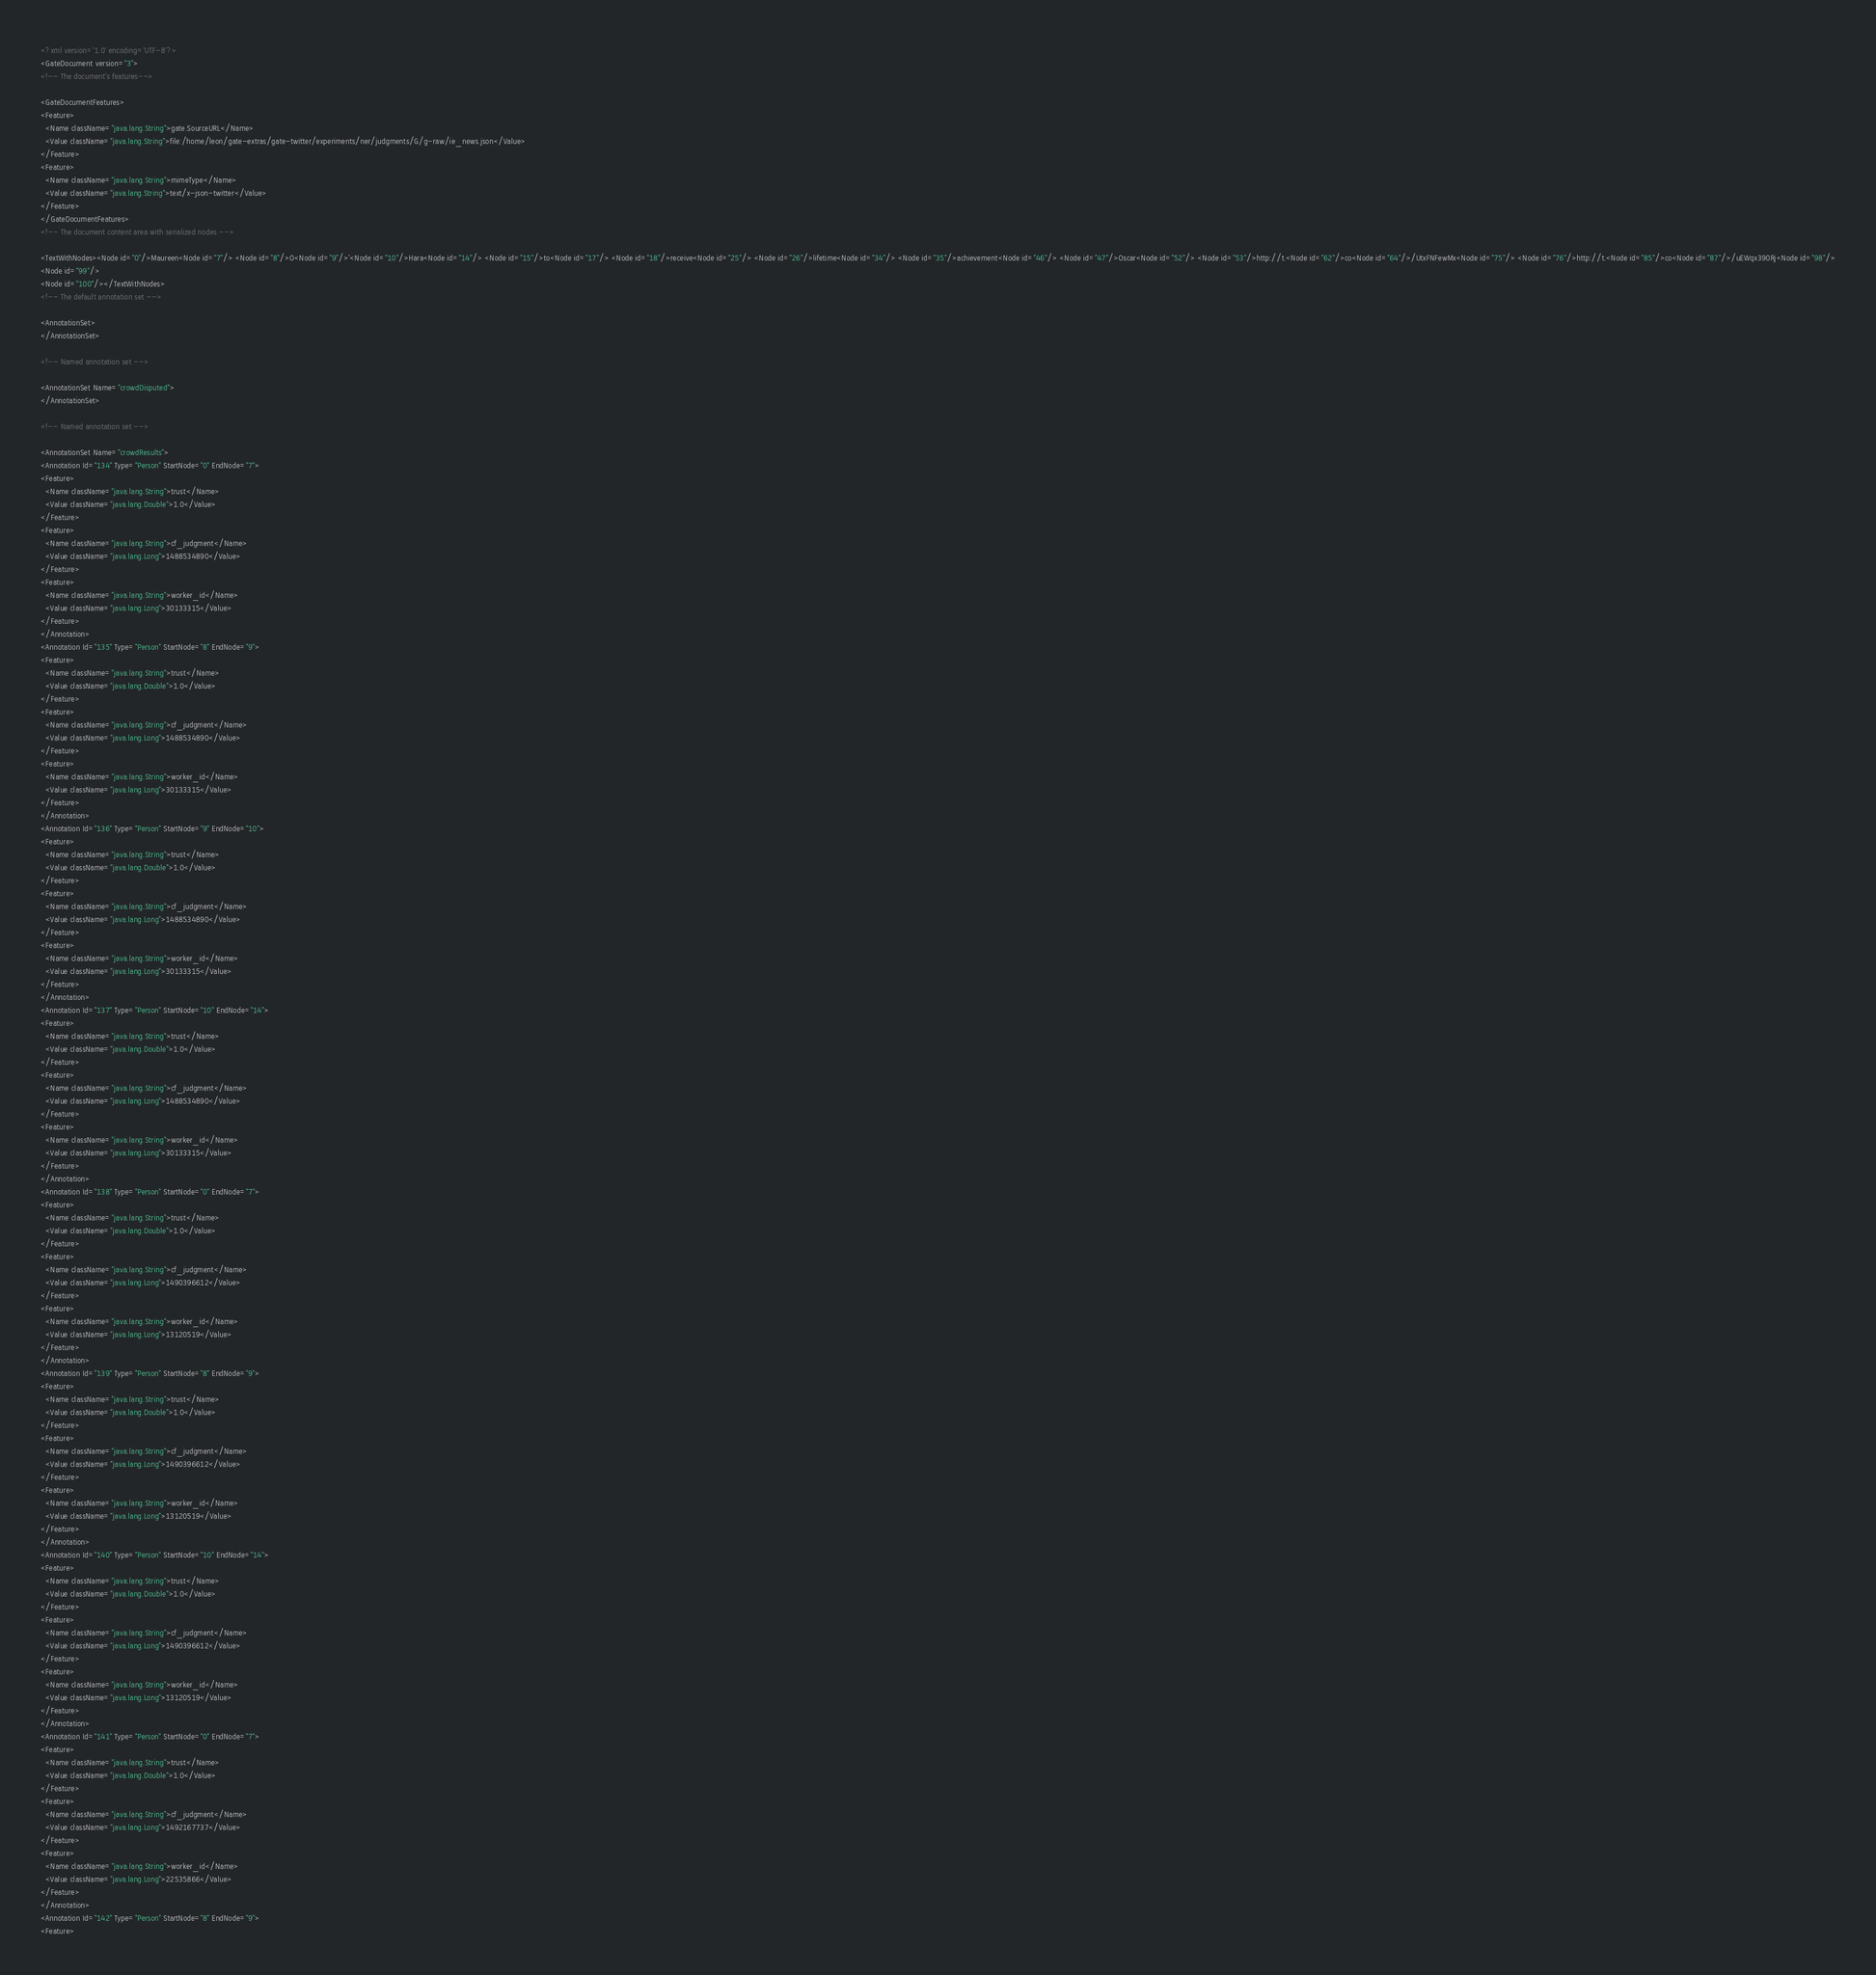Convert code to text. <code><loc_0><loc_0><loc_500><loc_500><_XML_><?xml version='1.0' encoding='UTF-8'?>
<GateDocument version="3">
<!-- The document's features-->

<GateDocumentFeatures>
<Feature>
  <Name className="java.lang.String">gate.SourceURL</Name>
  <Value className="java.lang.String">file:/home/leon/gate-extras/gate-twitter/experiments/ner/judgments/G/g-raw/ie_news.json</Value>
</Feature>
<Feature>
  <Name className="java.lang.String">mimeType</Name>
  <Value className="java.lang.String">text/x-json-twitter</Value>
</Feature>
</GateDocumentFeatures>
<!-- The document content area with serialized nodes -->

<TextWithNodes><Node id="0"/>Maureen<Node id="7"/> <Node id="8"/>O<Node id="9"/>'<Node id="10"/>Hara<Node id="14"/> <Node id="15"/>to<Node id="17"/> <Node id="18"/>receive<Node id="25"/> <Node id="26"/>lifetime<Node id="34"/> <Node id="35"/>achievement<Node id="46"/> <Node id="47"/>Oscar<Node id="52"/> <Node id="53"/>http://t.<Node id="62"/>co<Node id="64"/>/UtxFNFewMx<Node id="75"/> <Node id="76"/>http://t.<Node id="85"/>co<Node id="87"/>/uEWqx390Rj<Node id="98"/>
<Node id="99"/>
<Node id="100"/></TextWithNodes>
<!-- The default annotation set -->

<AnnotationSet>
</AnnotationSet>

<!-- Named annotation set -->

<AnnotationSet Name="crowdDisputed">
</AnnotationSet>

<!-- Named annotation set -->

<AnnotationSet Name="crowdResults">
<Annotation Id="134" Type="Person" StartNode="0" EndNode="7">
<Feature>
  <Name className="java.lang.String">trust</Name>
  <Value className="java.lang.Double">1.0</Value>
</Feature>
<Feature>
  <Name className="java.lang.String">cf_judgment</Name>
  <Value className="java.lang.Long">1488534890</Value>
</Feature>
<Feature>
  <Name className="java.lang.String">worker_id</Name>
  <Value className="java.lang.Long">30133315</Value>
</Feature>
</Annotation>
<Annotation Id="135" Type="Person" StartNode="8" EndNode="9">
<Feature>
  <Name className="java.lang.String">trust</Name>
  <Value className="java.lang.Double">1.0</Value>
</Feature>
<Feature>
  <Name className="java.lang.String">cf_judgment</Name>
  <Value className="java.lang.Long">1488534890</Value>
</Feature>
<Feature>
  <Name className="java.lang.String">worker_id</Name>
  <Value className="java.lang.Long">30133315</Value>
</Feature>
</Annotation>
<Annotation Id="136" Type="Person" StartNode="9" EndNode="10">
<Feature>
  <Name className="java.lang.String">trust</Name>
  <Value className="java.lang.Double">1.0</Value>
</Feature>
<Feature>
  <Name className="java.lang.String">cf_judgment</Name>
  <Value className="java.lang.Long">1488534890</Value>
</Feature>
<Feature>
  <Name className="java.lang.String">worker_id</Name>
  <Value className="java.lang.Long">30133315</Value>
</Feature>
</Annotation>
<Annotation Id="137" Type="Person" StartNode="10" EndNode="14">
<Feature>
  <Name className="java.lang.String">trust</Name>
  <Value className="java.lang.Double">1.0</Value>
</Feature>
<Feature>
  <Name className="java.lang.String">cf_judgment</Name>
  <Value className="java.lang.Long">1488534890</Value>
</Feature>
<Feature>
  <Name className="java.lang.String">worker_id</Name>
  <Value className="java.lang.Long">30133315</Value>
</Feature>
</Annotation>
<Annotation Id="138" Type="Person" StartNode="0" EndNode="7">
<Feature>
  <Name className="java.lang.String">trust</Name>
  <Value className="java.lang.Double">1.0</Value>
</Feature>
<Feature>
  <Name className="java.lang.String">cf_judgment</Name>
  <Value className="java.lang.Long">1490396612</Value>
</Feature>
<Feature>
  <Name className="java.lang.String">worker_id</Name>
  <Value className="java.lang.Long">13120519</Value>
</Feature>
</Annotation>
<Annotation Id="139" Type="Person" StartNode="8" EndNode="9">
<Feature>
  <Name className="java.lang.String">trust</Name>
  <Value className="java.lang.Double">1.0</Value>
</Feature>
<Feature>
  <Name className="java.lang.String">cf_judgment</Name>
  <Value className="java.lang.Long">1490396612</Value>
</Feature>
<Feature>
  <Name className="java.lang.String">worker_id</Name>
  <Value className="java.lang.Long">13120519</Value>
</Feature>
</Annotation>
<Annotation Id="140" Type="Person" StartNode="10" EndNode="14">
<Feature>
  <Name className="java.lang.String">trust</Name>
  <Value className="java.lang.Double">1.0</Value>
</Feature>
<Feature>
  <Name className="java.lang.String">cf_judgment</Name>
  <Value className="java.lang.Long">1490396612</Value>
</Feature>
<Feature>
  <Name className="java.lang.String">worker_id</Name>
  <Value className="java.lang.Long">13120519</Value>
</Feature>
</Annotation>
<Annotation Id="141" Type="Person" StartNode="0" EndNode="7">
<Feature>
  <Name className="java.lang.String">trust</Name>
  <Value className="java.lang.Double">1.0</Value>
</Feature>
<Feature>
  <Name className="java.lang.String">cf_judgment</Name>
  <Value className="java.lang.Long">1492167737</Value>
</Feature>
<Feature>
  <Name className="java.lang.String">worker_id</Name>
  <Value className="java.lang.Long">22535866</Value>
</Feature>
</Annotation>
<Annotation Id="142" Type="Person" StartNode="8" EndNode="9">
<Feature></code> 